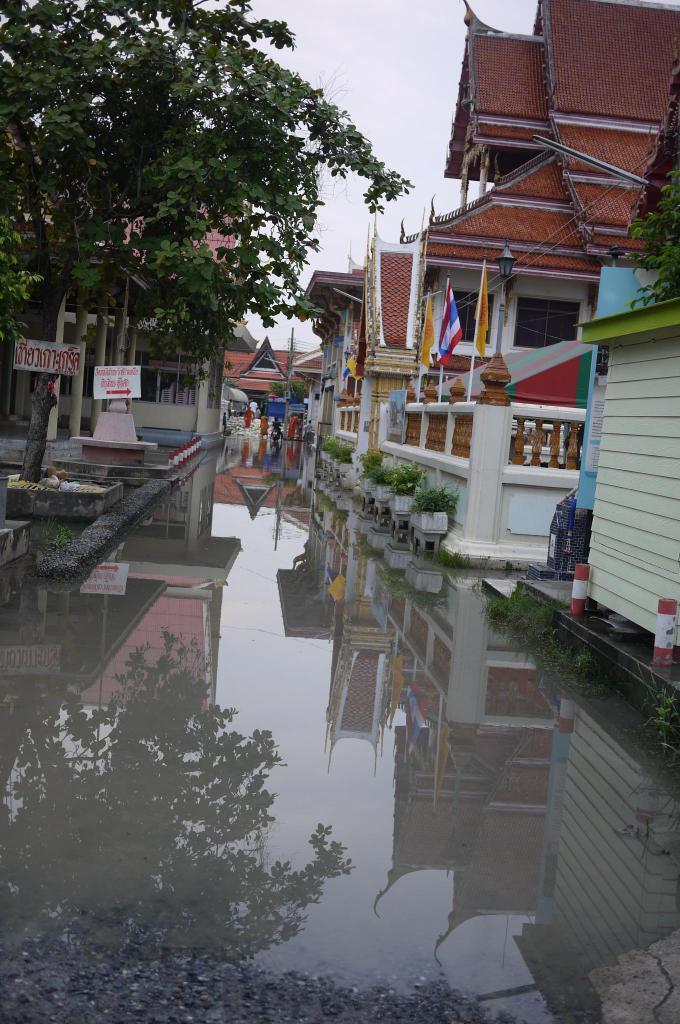Please provide a concise description of this image. In the image there is a lot of water on the road and beside the roads there are many houses and on the left side there are few trees and some boards are attached to the trees. 